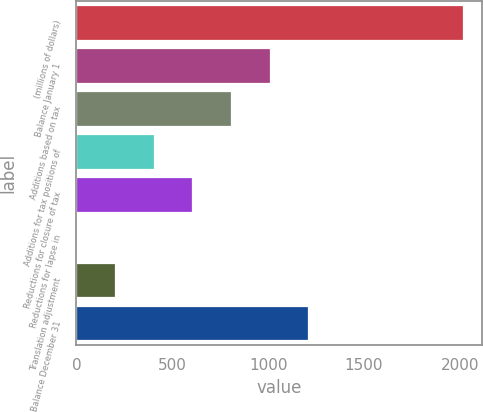Convert chart to OTSL. <chart><loc_0><loc_0><loc_500><loc_500><bar_chart><fcel>(millions of dollars)<fcel>Balance January 1<fcel>Additions based on tax<fcel>Additions for tax positions of<fcel>Reductions for closure of tax<fcel>Reductions for lapse in<fcel>Translation adjustment<fcel>Balance December 31<nl><fcel>2015<fcel>1007.65<fcel>806.18<fcel>403.24<fcel>604.71<fcel>0.3<fcel>201.77<fcel>1209.12<nl></chart> 